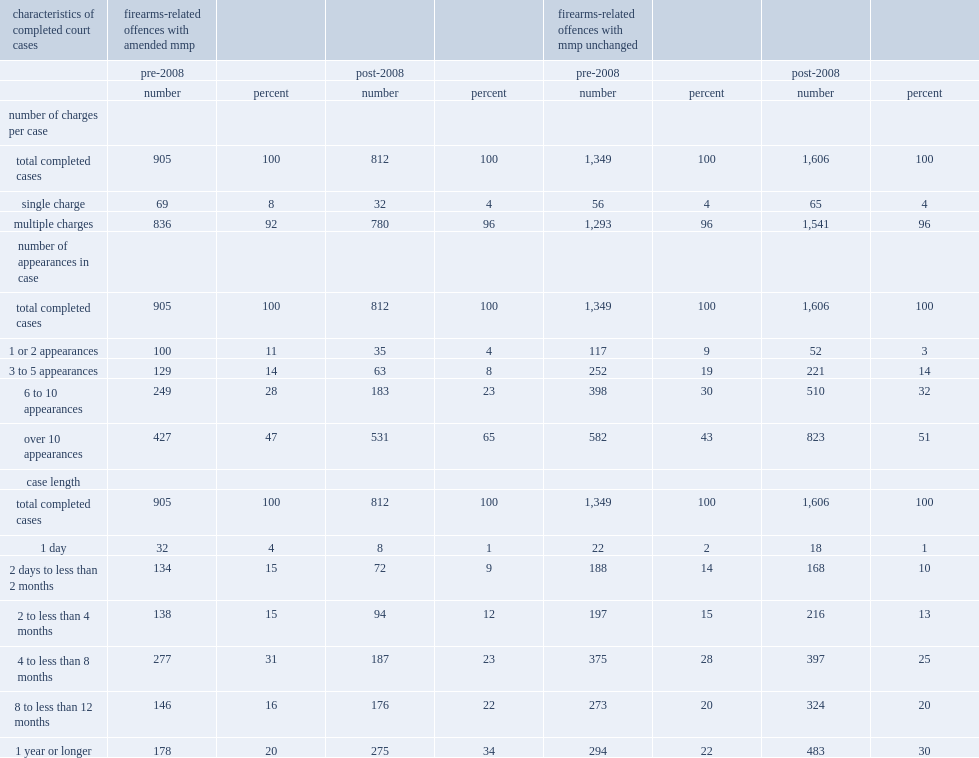What was the proportion of cases that involved multiple charges pre 2008 among amended groups? 92.0. What was the proportion of cases that involved multiple charges post 2008 among amended groups? 96.0. What was the proportion of cases that involved multiple charges pre 2008 among non-amended groups? 96.0. What was the proportion of cases that involved multiple charges post 2008 among non-amended groups? 96.0. What was the proportion of cases that involved ten or more court appearances pre 2008 among amended groups? 47.0. What was the proportion of cases that involved ten or more court appearances post 2008 among amended groups? 65.0. Among amended groups, which years had a higher proportion of cases that involved ten or more court appearances? Post-2008. What was the proportion of cases that involved ten or more court appearances pre 2008 among non-amended groups? 43.0. What was the proportion of cases that involved ten or more court appearances post 2008 among non-amended groups? 51.0. Among non-amended groups, which period had a higher proportion of cases that involved ten or more court appearances? Post-2008. 